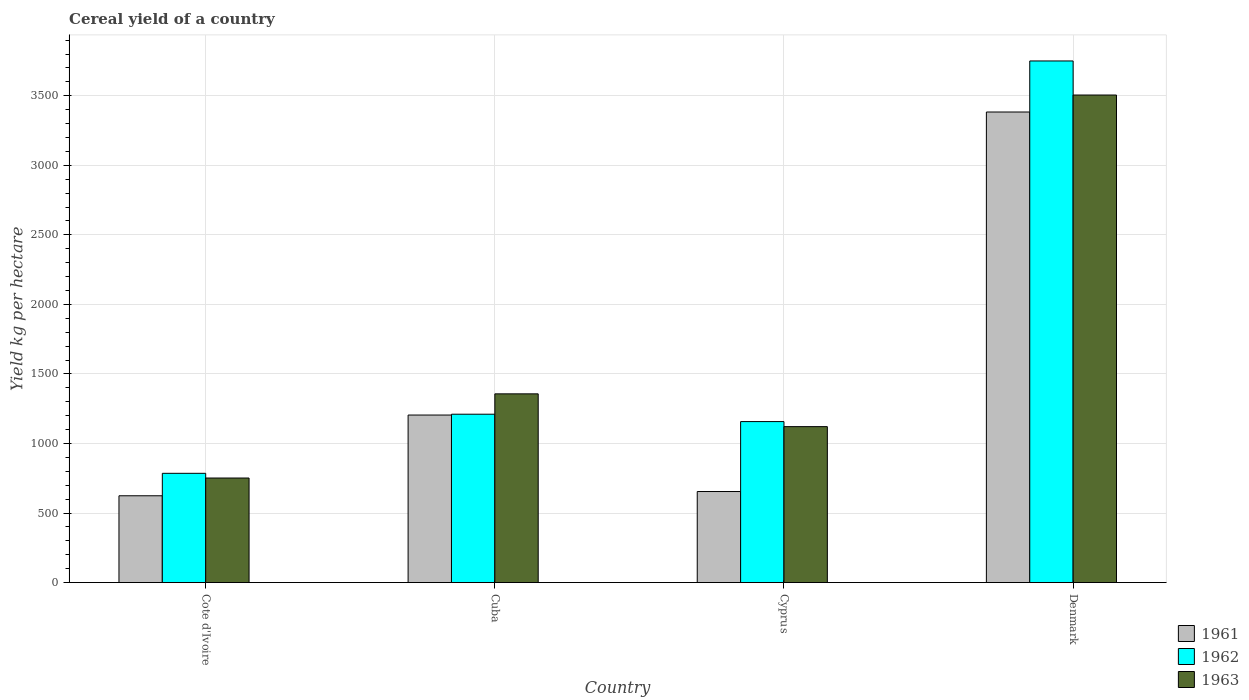How many different coloured bars are there?
Give a very brief answer. 3. How many bars are there on the 2nd tick from the left?
Your response must be concise. 3. What is the label of the 1st group of bars from the left?
Your answer should be compact. Cote d'Ivoire. What is the total cereal yield in 1961 in Denmark?
Make the answer very short. 3383.48. Across all countries, what is the maximum total cereal yield in 1961?
Provide a short and direct response. 3383.48. Across all countries, what is the minimum total cereal yield in 1963?
Make the answer very short. 751.88. In which country was the total cereal yield in 1961 maximum?
Your answer should be compact. Denmark. In which country was the total cereal yield in 1963 minimum?
Give a very brief answer. Cote d'Ivoire. What is the total total cereal yield in 1963 in the graph?
Make the answer very short. 6735.92. What is the difference between the total cereal yield in 1963 in Cyprus and that in Denmark?
Your answer should be very brief. -2384.35. What is the difference between the total cereal yield in 1963 in Denmark and the total cereal yield in 1961 in Cote d'Ivoire?
Your answer should be very brief. 2881.48. What is the average total cereal yield in 1963 per country?
Ensure brevity in your answer.  1683.98. What is the difference between the total cereal yield of/in 1962 and total cereal yield of/in 1963 in Cyprus?
Your response must be concise. 36.28. What is the ratio of the total cereal yield in 1961 in Cuba to that in Denmark?
Offer a terse response. 0.36. Is the total cereal yield in 1961 in Cote d'Ivoire less than that in Cuba?
Ensure brevity in your answer.  Yes. What is the difference between the highest and the second highest total cereal yield in 1962?
Your answer should be compact. 53.04. What is the difference between the highest and the lowest total cereal yield in 1961?
Your answer should be compact. 2759.27. What does the 1st bar from the left in Cuba represents?
Provide a short and direct response. 1961. Is it the case that in every country, the sum of the total cereal yield in 1961 and total cereal yield in 1962 is greater than the total cereal yield in 1963?
Ensure brevity in your answer.  Yes. Are all the bars in the graph horizontal?
Ensure brevity in your answer.  No. Are the values on the major ticks of Y-axis written in scientific E-notation?
Offer a terse response. No. Does the graph contain grids?
Provide a short and direct response. Yes. How many legend labels are there?
Provide a succinct answer. 3. How are the legend labels stacked?
Offer a very short reply. Vertical. What is the title of the graph?
Your answer should be compact. Cereal yield of a country. What is the label or title of the X-axis?
Offer a terse response. Country. What is the label or title of the Y-axis?
Your response must be concise. Yield kg per hectare. What is the Yield kg per hectare of 1961 in Cote d'Ivoire?
Keep it short and to the point. 624.2. What is the Yield kg per hectare of 1962 in Cote d'Ivoire?
Offer a very short reply. 785.71. What is the Yield kg per hectare of 1963 in Cote d'Ivoire?
Your answer should be very brief. 751.88. What is the Yield kg per hectare in 1961 in Cuba?
Offer a terse response. 1204.76. What is the Yield kg per hectare in 1962 in Cuba?
Give a very brief answer. 1210.66. What is the Yield kg per hectare of 1963 in Cuba?
Give a very brief answer. 1357.03. What is the Yield kg per hectare in 1961 in Cyprus?
Ensure brevity in your answer.  654.75. What is the Yield kg per hectare of 1962 in Cyprus?
Make the answer very short. 1157.61. What is the Yield kg per hectare of 1963 in Cyprus?
Give a very brief answer. 1121.33. What is the Yield kg per hectare in 1961 in Denmark?
Offer a very short reply. 3383.48. What is the Yield kg per hectare of 1962 in Denmark?
Give a very brief answer. 3750.59. What is the Yield kg per hectare in 1963 in Denmark?
Offer a very short reply. 3505.68. Across all countries, what is the maximum Yield kg per hectare of 1961?
Make the answer very short. 3383.48. Across all countries, what is the maximum Yield kg per hectare in 1962?
Make the answer very short. 3750.59. Across all countries, what is the maximum Yield kg per hectare of 1963?
Your answer should be very brief. 3505.68. Across all countries, what is the minimum Yield kg per hectare of 1961?
Provide a short and direct response. 624.2. Across all countries, what is the minimum Yield kg per hectare in 1962?
Provide a succinct answer. 785.71. Across all countries, what is the minimum Yield kg per hectare in 1963?
Provide a succinct answer. 751.88. What is the total Yield kg per hectare of 1961 in the graph?
Offer a terse response. 5867.19. What is the total Yield kg per hectare in 1962 in the graph?
Your response must be concise. 6904.58. What is the total Yield kg per hectare in 1963 in the graph?
Your response must be concise. 6735.92. What is the difference between the Yield kg per hectare in 1961 in Cote d'Ivoire and that in Cuba?
Offer a very short reply. -580.55. What is the difference between the Yield kg per hectare in 1962 in Cote d'Ivoire and that in Cuba?
Keep it short and to the point. -424.94. What is the difference between the Yield kg per hectare in 1963 in Cote d'Ivoire and that in Cuba?
Your answer should be very brief. -605.16. What is the difference between the Yield kg per hectare in 1961 in Cote d'Ivoire and that in Cyprus?
Provide a short and direct response. -30.55. What is the difference between the Yield kg per hectare in 1962 in Cote d'Ivoire and that in Cyprus?
Offer a terse response. -371.9. What is the difference between the Yield kg per hectare in 1963 in Cote d'Ivoire and that in Cyprus?
Offer a very short reply. -369.45. What is the difference between the Yield kg per hectare in 1961 in Cote d'Ivoire and that in Denmark?
Keep it short and to the point. -2759.27. What is the difference between the Yield kg per hectare in 1962 in Cote d'Ivoire and that in Denmark?
Make the answer very short. -2964.88. What is the difference between the Yield kg per hectare of 1963 in Cote d'Ivoire and that in Denmark?
Your answer should be compact. -2753.81. What is the difference between the Yield kg per hectare in 1961 in Cuba and that in Cyprus?
Offer a terse response. 550. What is the difference between the Yield kg per hectare of 1962 in Cuba and that in Cyprus?
Keep it short and to the point. 53.04. What is the difference between the Yield kg per hectare of 1963 in Cuba and that in Cyprus?
Your answer should be very brief. 235.71. What is the difference between the Yield kg per hectare in 1961 in Cuba and that in Denmark?
Make the answer very short. -2178.72. What is the difference between the Yield kg per hectare in 1962 in Cuba and that in Denmark?
Your response must be concise. -2539.94. What is the difference between the Yield kg per hectare in 1963 in Cuba and that in Denmark?
Your answer should be compact. -2148.65. What is the difference between the Yield kg per hectare of 1961 in Cyprus and that in Denmark?
Give a very brief answer. -2728.72. What is the difference between the Yield kg per hectare of 1962 in Cyprus and that in Denmark?
Offer a terse response. -2592.98. What is the difference between the Yield kg per hectare of 1963 in Cyprus and that in Denmark?
Keep it short and to the point. -2384.35. What is the difference between the Yield kg per hectare of 1961 in Cote d'Ivoire and the Yield kg per hectare of 1962 in Cuba?
Make the answer very short. -586.45. What is the difference between the Yield kg per hectare of 1961 in Cote d'Ivoire and the Yield kg per hectare of 1963 in Cuba?
Your response must be concise. -732.83. What is the difference between the Yield kg per hectare of 1962 in Cote d'Ivoire and the Yield kg per hectare of 1963 in Cuba?
Provide a short and direct response. -571.32. What is the difference between the Yield kg per hectare of 1961 in Cote d'Ivoire and the Yield kg per hectare of 1962 in Cyprus?
Make the answer very short. -533.41. What is the difference between the Yield kg per hectare of 1961 in Cote d'Ivoire and the Yield kg per hectare of 1963 in Cyprus?
Ensure brevity in your answer.  -497.12. What is the difference between the Yield kg per hectare of 1962 in Cote d'Ivoire and the Yield kg per hectare of 1963 in Cyprus?
Offer a very short reply. -335.62. What is the difference between the Yield kg per hectare in 1961 in Cote d'Ivoire and the Yield kg per hectare in 1962 in Denmark?
Offer a very short reply. -3126.39. What is the difference between the Yield kg per hectare of 1961 in Cote d'Ivoire and the Yield kg per hectare of 1963 in Denmark?
Give a very brief answer. -2881.48. What is the difference between the Yield kg per hectare of 1962 in Cote d'Ivoire and the Yield kg per hectare of 1963 in Denmark?
Offer a very short reply. -2719.97. What is the difference between the Yield kg per hectare in 1961 in Cuba and the Yield kg per hectare in 1962 in Cyprus?
Make the answer very short. 47.14. What is the difference between the Yield kg per hectare in 1961 in Cuba and the Yield kg per hectare in 1963 in Cyprus?
Provide a short and direct response. 83.43. What is the difference between the Yield kg per hectare of 1962 in Cuba and the Yield kg per hectare of 1963 in Cyprus?
Provide a succinct answer. 89.33. What is the difference between the Yield kg per hectare of 1961 in Cuba and the Yield kg per hectare of 1962 in Denmark?
Your answer should be very brief. -2545.84. What is the difference between the Yield kg per hectare in 1961 in Cuba and the Yield kg per hectare in 1963 in Denmark?
Your answer should be compact. -2300.93. What is the difference between the Yield kg per hectare of 1962 in Cuba and the Yield kg per hectare of 1963 in Denmark?
Keep it short and to the point. -2295.03. What is the difference between the Yield kg per hectare in 1961 in Cyprus and the Yield kg per hectare in 1962 in Denmark?
Ensure brevity in your answer.  -3095.84. What is the difference between the Yield kg per hectare in 1961 in Cyprus and the Yield kg per hectare in 1963 in Denmark?
Provide a succinct answer. -2850.93. What is the difference between the Yield kg per hectare in 1962 in Cyprus and the Yield kg per hectare in 1963 in Denmark?
Your answer should be compact. -2348.07. What is the average Yield kg per hectare of 1961 per country?
Your answer should be compact. 1466.8. What is the average Yield kg per hectare in 1962 per country?
Give a very brief answer. 1726.14. What is the average Yield kg per hectare in 1963 per country?
Provide a succinct answer. 1683.98. What is the difference between the Yield kg per hectare in 1961 and Yield kg per hectare in 1962 in Cote d'Ivoire?
Your answer should be very brief. -161.51. What is the difference between the Yield kg per hectare of 1961 and Yield kg per hectare of 1963 in Cote d'Ivoire?
Make the answer very short. -127.67. What is the difference between the Yield kg per hectare of 1962 and Yield kg per hectare of 1963 in Cote d'Ivoire?
Your answer should be compact. 33.84. What is the difference between the Yield kg per hectare in 1961 and Yield kg per hectare in 1962 in Cuba?
Keep it short and to the point. -5.9. What is the difference between the Yield kg per hectare of 1961 and Yield kg per hectare of 1963 in Cuba?
Your answer should be compact. -152.28. What is the difference between the Yield kg per hectare of 1962 and Yield kg per hectare of 1963 in Cuba?
Your response must be concise. -146.38. What is the difference between the Yield kg per hectare of 1961 and Yield kg per hectare of 1962 in Cyprus?
Give a very brief answer. -502.86. What is the difference between the Yield kg per hectare of 1961 and Yield kg per hectare of 1963 in Cyprus?
Your answer should be very brief. -466.57. What is the difference between the Yield kg per hectare of 1962 and Yield kg per hectare of 1963 in Cyprus?
Provide a short and direct response. 36.28. What is the difference between the Yield kg per hectare of 1961 and Yield kg per hectare of 1962 in Denmark?
Provide a succinct answer. -367.12. What is the difference between the Yield kg per hectare of 1961 and Yield kg per hectare of 1963 in Denmark?
Provide a short and direct response. -122.2. What is the difference between the Yield kg per hectare of 1962 and Yield kg per hectare of 1963 in Denmark?
Your answer should be compact. 244.91. What is the ratio of the Yield kg per hectare of 1961 in Cote d'Ivoire to that in Cuba?
Your response must be concise. 0.52. What is the ratio of the Yield kg per hectare in 1962 in Cote d'Ivoire to that in Cuba?
Provide a short and direct response. 0.65. What is the ratio of the Yield kg per hectare of 1963 in Cote d'Ivoire to that in Cuba?
Provide a succinct answer. 0.55. What is the ratio of the Yield kg per hectare in 1961 in Cote d'Ivoire to that in Cyprus?
Give a very brief answer. 0.95. What is the ratio of the Yield kg per hectare in 1962 in Cote d'Ivoire to that in Cyprus?
Give a very brief answer. 0.68. What is the ratio of the Yield kg per hectare of 1963 in Cote d'Ivoire to that in Cyprus?
Your response must be concise. 0.67. What is the ratio of the Yield kg per hectare in 1961 in Cote d'Ivoire to that in Denmark?
Provide a succinct answer. 0.18. What is the ratio of the Yield kg per hectare of 1962 in Cote d'Ivoire to that in Denmark?
Keep it short and to the point. 0.21. What is the ratio of the Yield kg per hectare of 1963 in Cote d'Ivoire to that in Denmark?
Offer a terse response. 0.21. What is the ratio of the Yield kg per hectare in 1961 in Cuba to that in Cyprus?
Give a very brief answer. 1.84. What is the ratio of the Yield kg per hectare of 1962 in Cuba to that in Cyprus?
Provide a succinct answer. 1.05. What is the ratio of the Yield kg per hectare of 1963 in Cuba to that in Cyprus?
Ensure brevity in your answer.  1.21. What is the ratio of the Yield kg per hectare in 1961 in Cuba to that in Denmark?
Provide a short and direct response. 0.36. What is the ratio of the Yield kg per hectare of 1962 in Cuba to that in Denmark?
Offer a terse response. 0.32. What is the ratio of the Yield kg per hectare in 1963 in Cuba to that in Denmark?
Your answer should be compact. 0.39. What is the ratio of the Yield kg per hectare in 1961 in Cyprus to that in Denmark?
Keep it short and to the point. 0.19. What is the ratio of the Yield kg per hectare of 1962 in Cyprus to that in Denmark?
Provide a short and direct response. 0.31. What is the ratio of the Yield kg per hectare of 1963 in Cyprus to that in Denmark?
Give a very brief answer. 0.32. What is the difference between the highest and the second highest Yield kg per hectare in 1961?
Make the answer very short. 2178.72. What is the difference between the highest and the second highest Yield kg per hectare in 1962?
Keep it short and to the point. 2539.94. What is the difference between the highest and the second highest Yield kg per hectare in 1963?
Your response must be concise. 2148.65. What is the difference between the highest and the lowest Yield kg per hectare of 1961?
Offer a terse response. 2759.27. What is the difference between the highest and the lowest Yield kg per hectare of 1962?
Give a very brief answer. 2964.88. What is the difference between the highest and the lowest Yield kg per hectare in 1963?
Provide a short and direct response. 2753.81. 